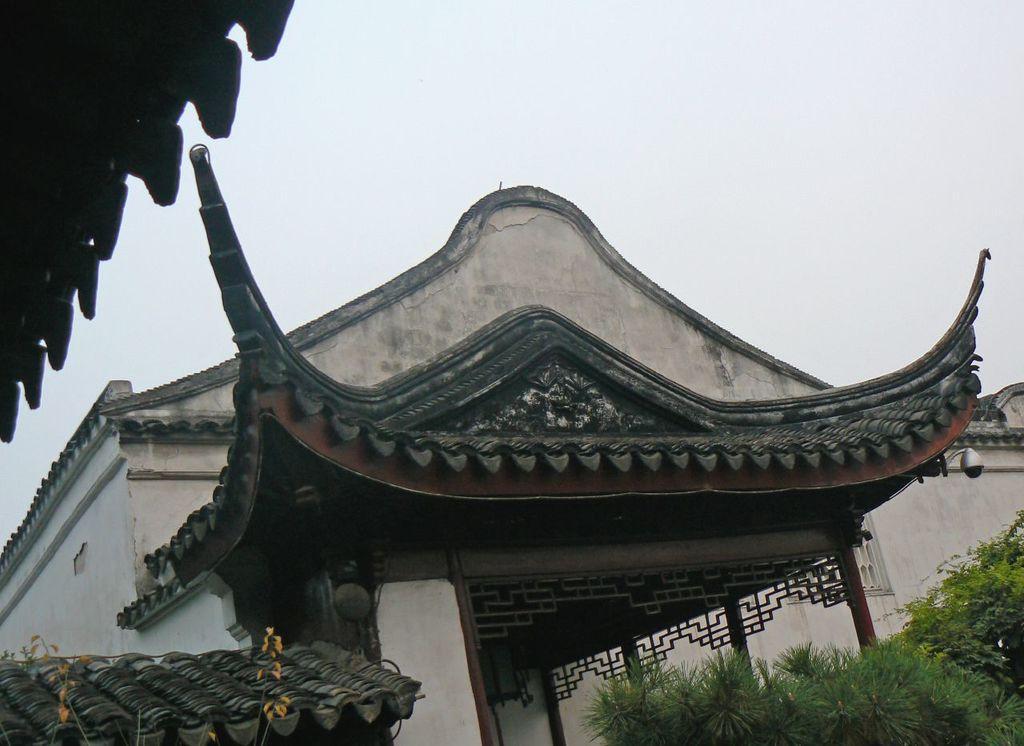In one or two sentences, can you explain what this image depicts? In this image there is a house, in the bottom right there are plants, in the top left there is a roof, in the background there is the sky. 